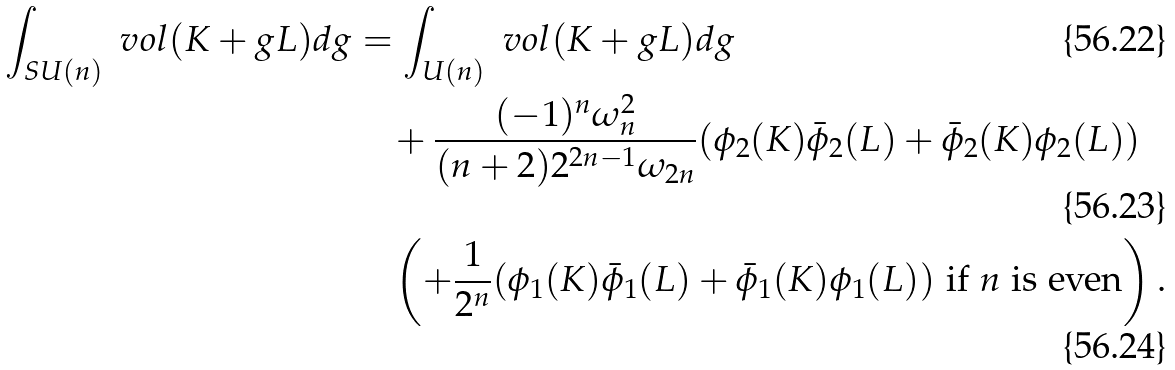<formula> <loc_0><loc_0><loc_500><loc_500>\int _ { S U ( n ) } \ v o l ( K + g L ) d g & = \int _ { U ( n ) } \ v o l ( K + g L ) d g \\ & \quad + \frac { ( - 1 ) ^ { n } \omega _ { n } ^ { 2 } } { ( n + 2 ) 2 ^ { 2 n - 1 } \omega _ { 2 n } } ( \phi _ { 2 } ( K ) \bar { \phi } _ { 2 } ( L ) + \bar { \phi } _ { 2 } ( K ) \phi _ { 2 } ( L ) ) \\ & \quad \left ( + \frac { 1 } { 2 ^ { n } } ( \phi _ { 1 } ( K ) \bar { \phi } _ { 1 } ( L ) + \bar { \phi } _ { 1 } ( K ) \phi _ { 1 } ( L ) ) \text { if } n \text { is even} \right ) .</formula> 